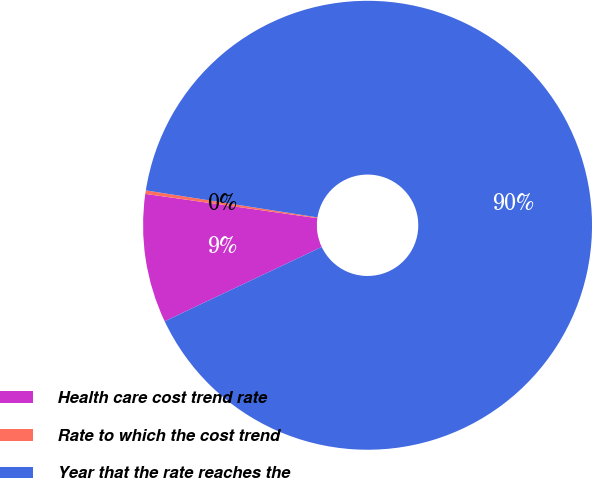<chart> <loc_0><loc_0><loc_500><loc_500><pie_chart><fcel>Health care cost trend rate<fcel>Rate to which the cost trend<fcel>Year that the rate reaches the<nl><fcel>9.27%<fcel>0.25%<fcel>90.48%<nl></chart> 